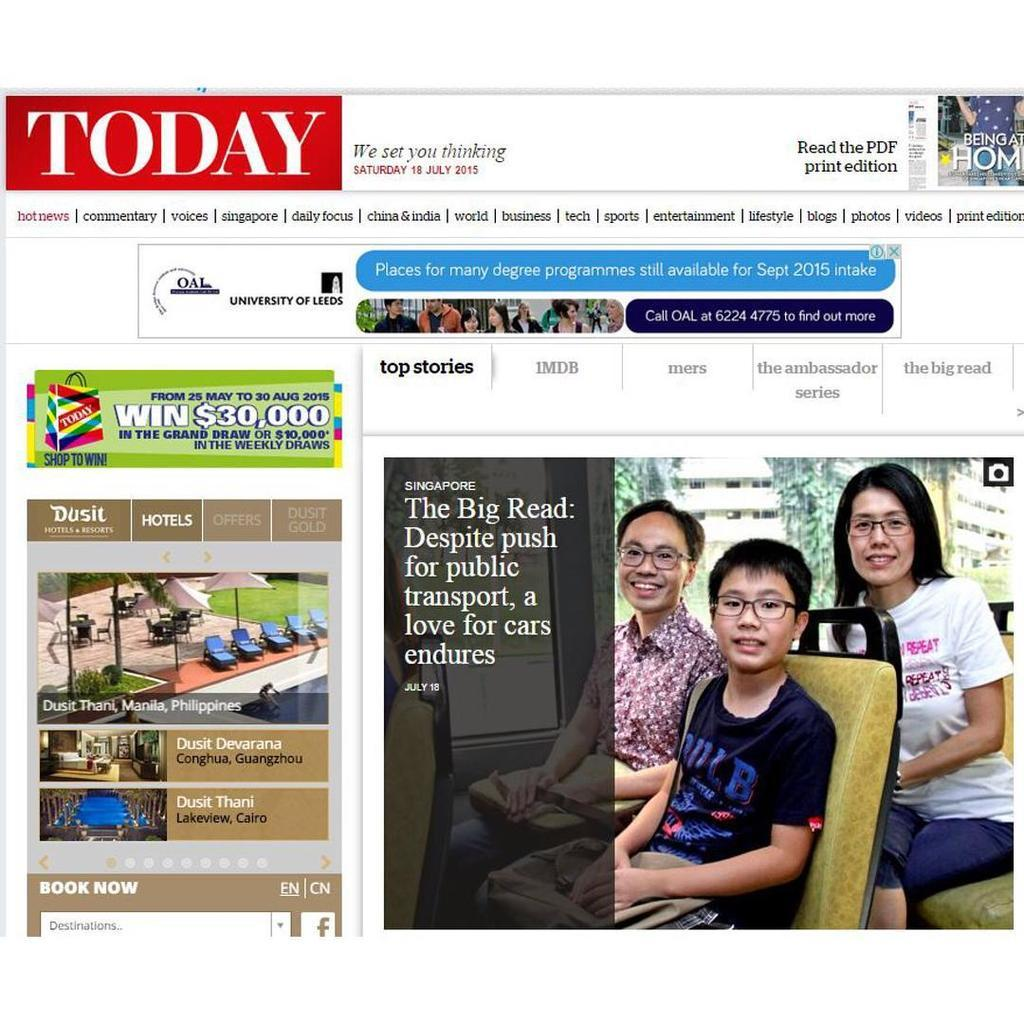<image>
Share a concise interpretation of the image provided. Today's website, which is dated Saturday July 18, 2015. 